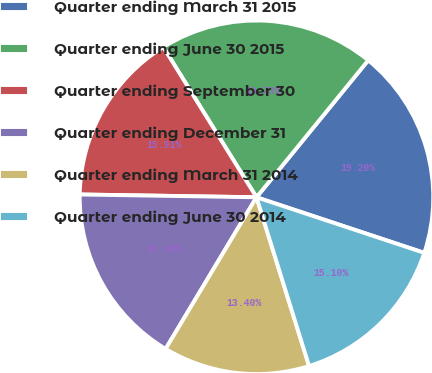<chart> <loc_0><loc_0><loc_500><loc_500><pie_chart><fcel>Quarter ending March 31 2015<fcel>Quarter ending June 30 2015<fcel>Quarter ending September 30<fcel>Quarter ending December 31<fcel>Quarter ending March 31 2014<fcel>Quarter ending June 30 2014<nl><fcel>19.2%<fcel>19.73%<fcel>15.91%<fcel>16.66%<fcel>13.4%<fcel>15.1%<nl></chart> 